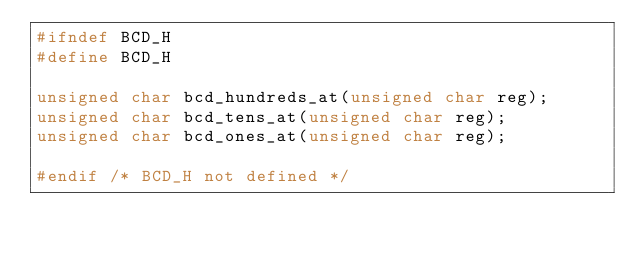<code> <loc_0><loc_0><loc_500><loc_500><_C_>#ifndef BCD_H
#define BCD_H

unsigned char bcd_hundreds_at(unsigned char reg);
unsigned char bcd_tens_at(unsigned char reg);
unsigned char bcd_ones_at(unsigned char reg);

#endif /* BCD_H not defined */</code> 